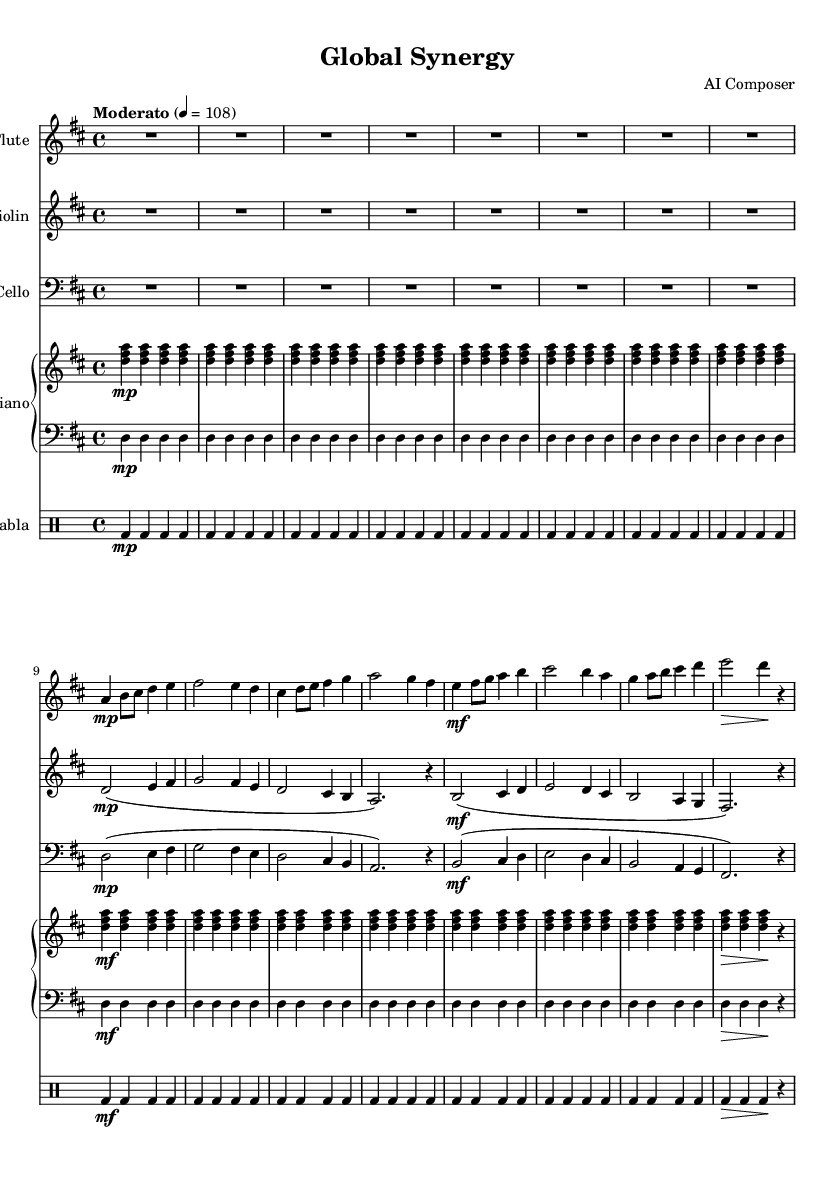What is the key signature of this music? The key signature is two sharps (F# and C#), indicating that the piece is in D major. This is visible at the beginning of the staff where the key signature symbols are placed.
Answer: D major What is the time signature of this music? The time signature is 4/4, which indicates that there are four beats in each measure and the quarter note receives one beat. This is denoted at the beginning of the score, right after the key signature.
Answer: 4/4 What is the tempo marking in this piece? The tempo marking is "Moderato," which suggests a moderate speed for the performance. This is indicated above the staff in the score, specifying the desired speed of the piece.
Answer: Moderato Which instruments are included in the score? The score includes Flute, Violin, Cello, Piano, and Tabla. This information can be found in the headers above each staff, listing the respective instruments.
Answer: Flute, Violin, Cello, Piano, Tabla How many measures are in the piece? The piece contains 16 measures, counting each vertical barline in the score. Each measure is defined by the space between the barlines, and by counting these, the total is determined.
Answer: 16 What is the dynamic marking for the flute in measures 1 to 4? The dynamic marking for the flute in measures 1 to 4 is "mp" (mezzo-piano), which indicates a moderately soft volume. This marking appears at the beginning of measure 2 and is a performance instruction for the musician.
Answer: mp Which clef is used for the cello part? The cello part uses the bass clef, which is indicated at the beginning of the cello staff. The bass clef is specifically designed for lower-pitched instruments like the cello.
Answer: Bass clef 